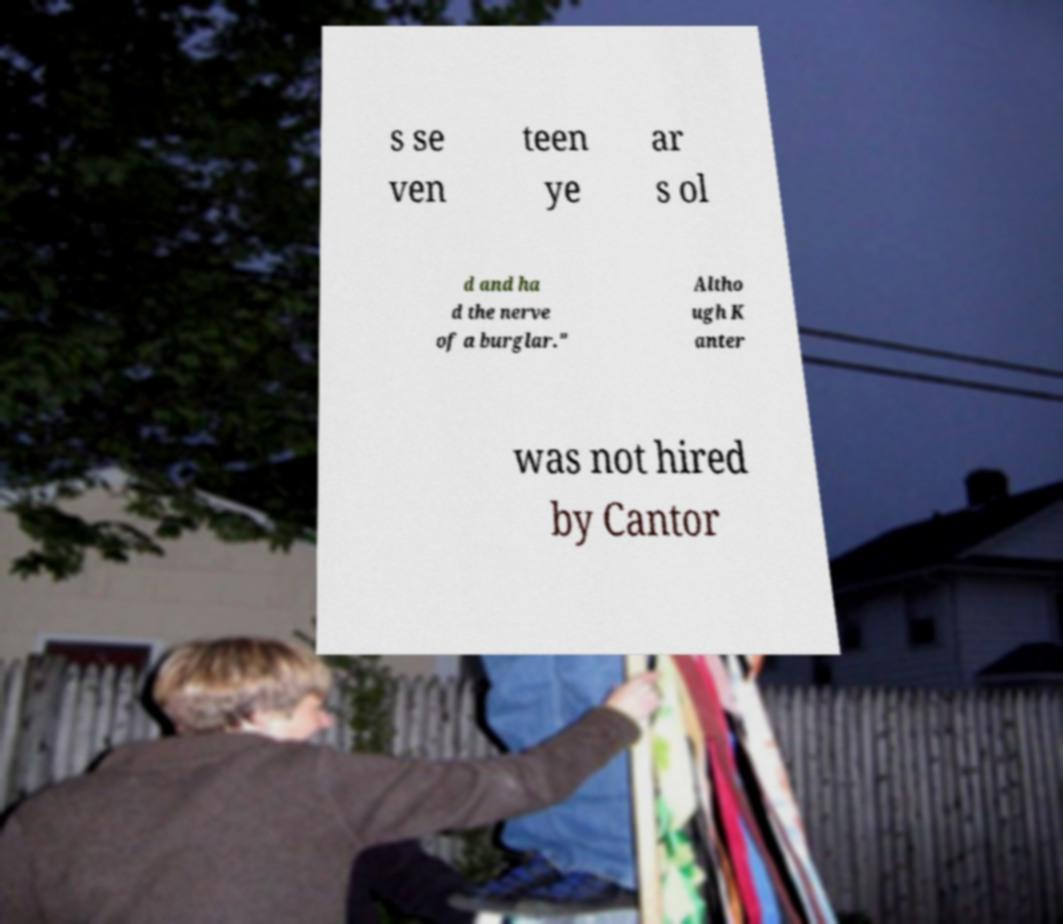Please read and relay the text visible in this image. What does it say? s se ven teen ye ar s ol d and ha d the nerve of a burglar." Altho ugh K anter was not hired by Cantor 